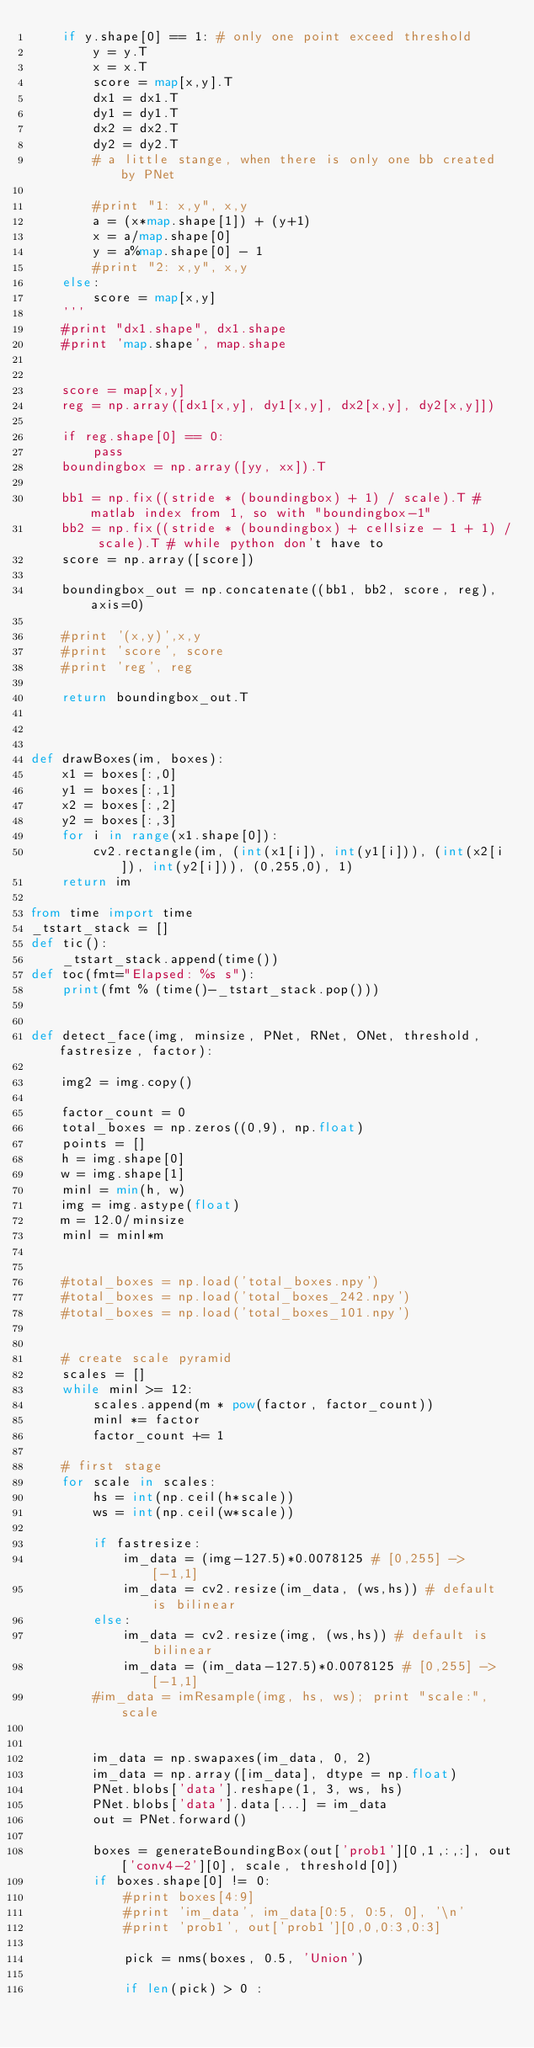Convert code to text. <code><loc_0><loc_0><loc_500><loc_500><_Python_>    if y.shape[0] == 1: # only one point exceed threshold
        y = y.T
        x = x.T
        score = map[x,y].T
        dx1 = dx1.T
        dy1 = dy1.T
        dx2 = dx2.T
        dy2 = dy2.T
        # a little stange, when there is only one bb created by PNet
        
        #print "1: x,y", x,y
        a = (x*map.shape[1]) + (y+1)
        x = a/map.shape[0]
        y = a%map.shape[0] - 1
        #print "2: x,y", x,y
    else:
        score = map[x,y]
    '''
    #print "dx1.shape", dx1.shape
    #print 'map.shape', map.shape
   

    score = map[x,y]
    reg = np.array([dx1[x,y], dy1[x,y], dx2[x,y], dy2[x,y]])

    if reg.shape[0] == 0:
        pass
    boundingbox = np.array([yy, xx]).T

    bb1 = np.fix((stride * (boundingbox) + 1) / scale).T # matlab index from 1, so with "boundingbox-1"
    bb2 = np.fix((stride * (boundingbox) + cellsize - 1 + 1) / scale).T # while python don't have to
    score = np.array([score])

    boundingbox_out = np.concatenate((bb1, bb2, score, reg), axis=0)

    #print '(x,y)',x,y
    #print 'score', score
    #print 'reg', reg

    return boundingbox_out.T



def drawBoxes(im, boxes):
    x1 = boxes[:,0]
    y1 = boxes[:,1]
    x2 = boxes[:,2]
    y2 = boxes[:,3]
    for i in range(x1.shape[0]):
        cv2.rectangle(im, (int(x1[i]), int(y1[i])), (int(x2[i]), int(y2[i])), (0,255,0), 1)
    return im

from time import time
_tstart_stack = []
def tic():
    _tstart_stack.append(time())
def toc(fmt="Elapsed: %s s"):
    print(fmt % (time()-_tstart_stack.pop()))


def detect_face(img, minsize, PNet, RNet, ONet, threshold, fastresize, factor):
    
    img2 = img.copy()

    factor_count = 0
    total_boxes = np.zeros((0,9), np.float)
    points = []
    h = img.shape[0]
    w = img.shape[1]
    minl = min(h, w)
    img = img.astype(float)
    m = 12.0/minsize
    minl = minl*m
    

    #total_boxes = np.load('total_boxes.npy')
    #total_boxes = np.load('total_boxes_242.npy')
    #total_boxes = np.load('total_boxes_101.npy')

    
    # create scale pyramid
    scales = []
    while minl >= 12:
        scales.append(m * pow(factor, factor_count))
        minl *= factor
        factor_count += 1
    
    # first stage
    for scale in scales:
        hs = int(np.ceil(h*scale))
        ws = int(np.ceil(w*scale))

        if fastresize:
            im_data = (img-127.5)*0.0078125 # [0,255] -> [-1,1]
            im_data = cv2.resize(im_data, (ws,hs)) # default is bilinear
        else: 
            im_data = cv2.resize(img, (ws,hs)) # default is bilinear
            im_data = (im_data-127.5)*0.0078125 # [0,255] -> [-1,1]
        #im_data = imResample(img, hs, ws); print "scale:", scale


        im_data = np.swapaxes(im_data, 0, 2)
        im_data = np.array([im_data], dtype = np.float)
        PNet.blobs['data'].reshape(1, 3, ws, hs)
        PNet.blobs['data'].data[...] = im_data
        out = PNet.forward()
    
        boxes = generateBoundingBox(out['prob1'][0,1,:,:], out['conv4-2'][0], scale, threshold[0])
        if boxes.shape[0] != 0:
            #print boxes[4:9]
            #print 'im_data', im_data[0:5, 0:5, 0], '\n'
            #print 'prob1', out['prob1'][0,0,0:3,0:3]

            pick = nms(boxes, 0.5, 'Union')

            if len(pick) > 0 :</code> 